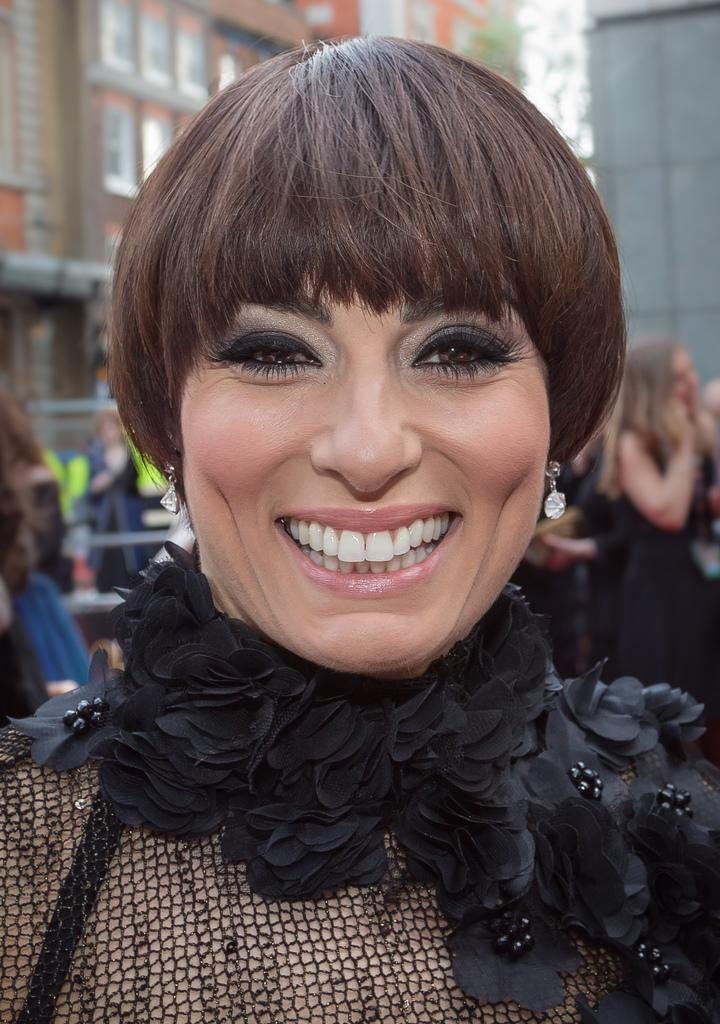Who is the main subject in the image? There is a lady in the image. What can be seen in the background of the image? Buildings are visible in the background of the image. What type of muscle is being flexed by the lady in the image? There is no indication in the image that the lady is flexing any muscles, so it cannot be determined from the picture. 